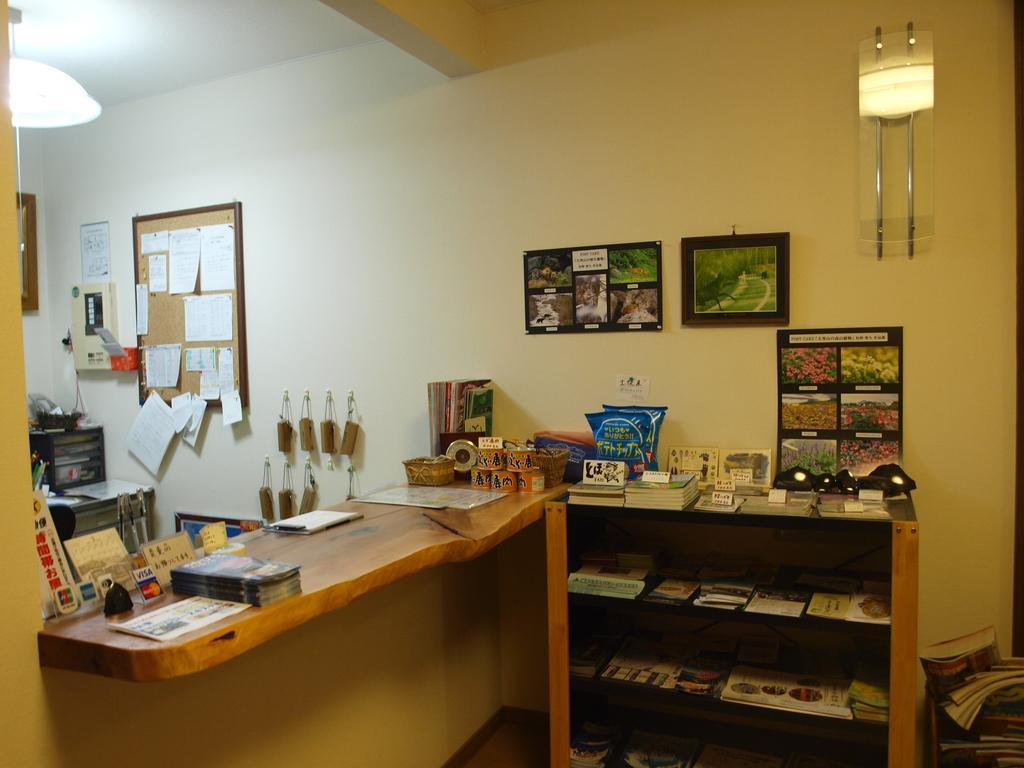In one or two sentences, can you explain what this image depicts? In this picture we have a table and on the table we can see books, paper, notepad,basket,boxes and right of the table here it is a rack full of books and left of the table we have printing machine and above that attached to the wall we have notice board ticked with the stickers and a light above it and frames and packets placed over the rack. 